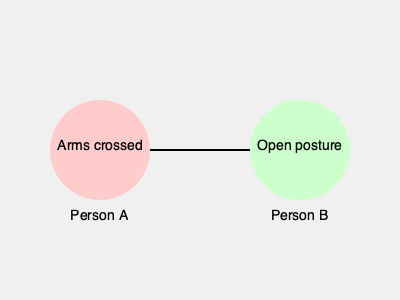In a group therapy session, you observe two clients interacting as shown in the image. Person A has their arms crossed, while Person B displays an open posture. As a psychotherapist focusing on identity development, how might you interpret this body language in terms of each person's current state of identity formation? 1. Analyze Person A's body language:
   - Arms crossed: Often indicates defensiveness, discomfort, or closed-off attitude
   - This may suggest a less developed or insecure sense of identity

2. Analyze Person B's body language:
   - Open posture: Usually signifies openness, confidence, and receptiveness
   - This may indicate a more developed or secure sense of identity

3. Consider the interaction between A and B:
   - The contrast in body language might suggest different stages of identity development
   - Person A may feel threatened or challenged by Person B's apparent confidence

4. Relate to identity development theories:
   - Erik Erikson's stages of psychosocial development: Person A might be struggling with identity vs. role confusion, while Person B may have achieved a stronger sense of identity

5. Therapeutic implications:
   - Focus on helping Person A explore and develop their identity more fully
   - Encourage Person B to share their experiences of identity formation
   - Use the group dynamic to foster mutual understanding and growth

6. Conclusion:
   Body language indicates Person A may have a less developed sense of identity compared to Person B, suggesting different stages in the identity formation process.
Answer: Different stages of identity formation: A less developed, B more developed 